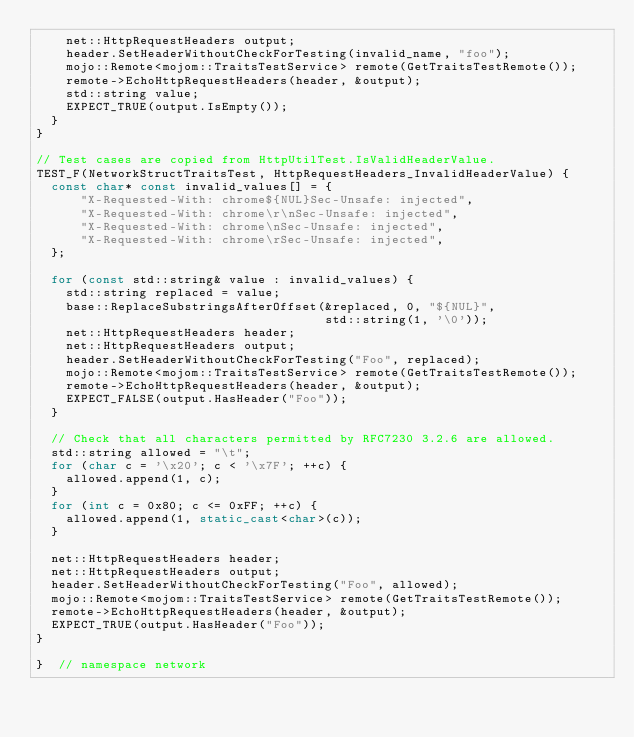Convert code to text. <code><loc_0><loc_0><loc_500><loc_500><_C++_>    net::HttpRequestHeaders output;
    header.SetHeaderWithoutCheckForTesting(invalid_name, "foo");
    mojo::Remote<mojom::TraitsTestService> remote(GetTraitsTestRemote());
    remote->EchoHttpRequestHeaders(header, &output);
    std::string value;
    EXPECT_TRUE(output.IsEmpty());
  }
}

// Test cases are copied from HttpUtilTest.IsValidHeaderValue.
TEST_F(NetworkStructTraitsTest, HttpRequestHeaders_InvalidHeaderValue) {
  const char* const invalid_values[] = {
      "X-Requested-With: chrome${NUL}Sec-Unsafe: injected",
      "X-Requested-With: chrome\r\nSec-Unsafe: injected",
      "X-Requested-With: chrome\nSec-Unsafe: injected",
      "X-Requested-With: chrome\rSec-Unsafe: injected",
  };

  for (const std::string& value : invalid_values) {
    std::string replaced = value;
    base::ReplaceSubstringsAfterOffset(&replaced, 0, "${NUL}",
                                       std::string(1, '\0'));
    net::HttpRequestHeaders header;
    net::HttpRequestHeaders output;
    header.SetHeaderWithoutCheckForTesting("Foo", replaced);
    mojo::Remote<mojom::TraitsTestService> remote(GetTraitsTestRemote());
    remote->EchoHttpRequestHeaders(header, &output);
    EXPECT_FALSE(output.HasHeader("Foo"));
  }

  // Check that all characters permitted by RFC7230 3.2.6 are allowed.
  std::string allowed = "\t";
  for (char c = '\x20'; c < '\x7F'; ++c) {
    allowed.append(1, c);
  }
  for (int c = 0x80; c <= 0xFF; ++c) {
    allowed.append(1, static_cast<char>(c));
  }

  net::HttpRequestHeaders header;
  net::HttpRequestHeaders output;
  header.SetHeaderWithoutCheckForTesting("Foo", allowed);
  mojo::Remote<mojom::TraitsTestService> remote(GetTraitsTestRemote());
  remote->EchoHttpRequestHeaders(header, &output);
  EXPECT_TRUE(output.HasHeader("Foo"));
}

}  // namespace network
</code> 